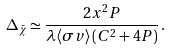<formula> <loc_0><loc_0><loc_500><loc_500>\Delta _ { \bar { \chi } } \simeq \frac { 2 x ^ { 2 } P } { \lambda \langle \sigma v \rangle \, ( C ^ { 2 } + 4 P ) } \, .</formula> 